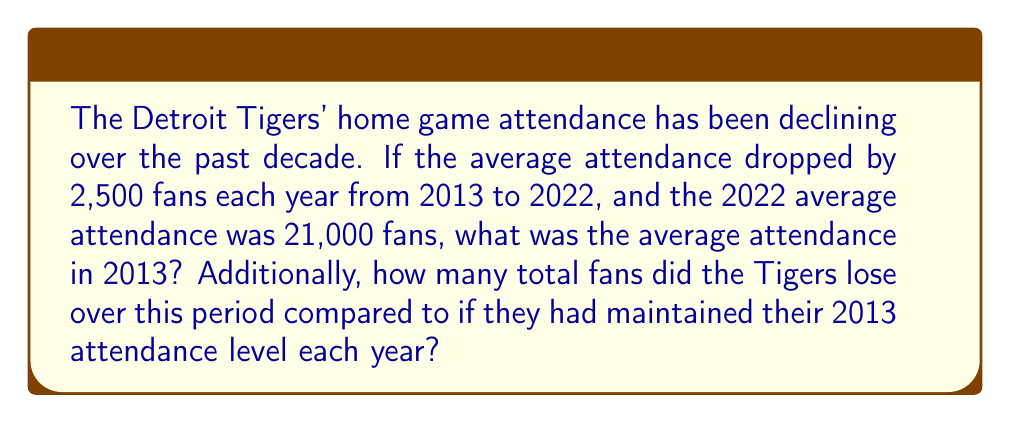Can you answer this question? Let's approach this step-by-step:

1) First, we need to find the 2013 attendance. We know:
   - The decline is 2,500 fans per year
   - This decline occurred over 9 years (2013 to 2022)
   - The 2022 attendance was 21,000

   So, we can set up the equation:
   $$ 2013\text{ attendance} - (9 \times 2,500) = 21,000 $$

2) Solving for 2013 attendance:
   $$ 2013\text{ attendance} = 21,000 + (9 \times 2,500) = 21,000 + 22,500 = 43,500 $$

3) Now, to find the total fans lost, we need to:
   a) Calculate the actual total attendance over the 10 years
   b) Calculate what the attendance would have been if it stayed at 43,500
   c) Subtract (a) from (b)

4) The actual attendance forms an arithmetic sequence with:
   - First term $a_1 = 43,500$
   - Last term $a_{10} = 21,000$
   - Number of terms $n = 10$

   We can use the arithmetic sequence sum formula:
   $$ S_n = \frac{n}{2}(a_1 + a_n) = \frac{10}{2}(43,500 + 21,000) = 5 \times 64,500 = 322,500 $$

5) If attendance stayed at 43,500 for 10 years:
   $$ 43,500 \times 10 = 435,000 $$

6) The difference:
   $$ 435,000 - 322,500 = 112,500 $$

Therefore, the Tigers lost 112,500 fans over this period compared to maintaining the 2013 level.
Answer: 43,500 fans; 112,500 fans lost 